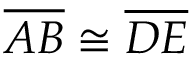Convert formula to latex. <formula><loc_0><loc_0><loc_500><loc_500>{ \overline { A B } } \cong { \overline { D E } }</formula> 